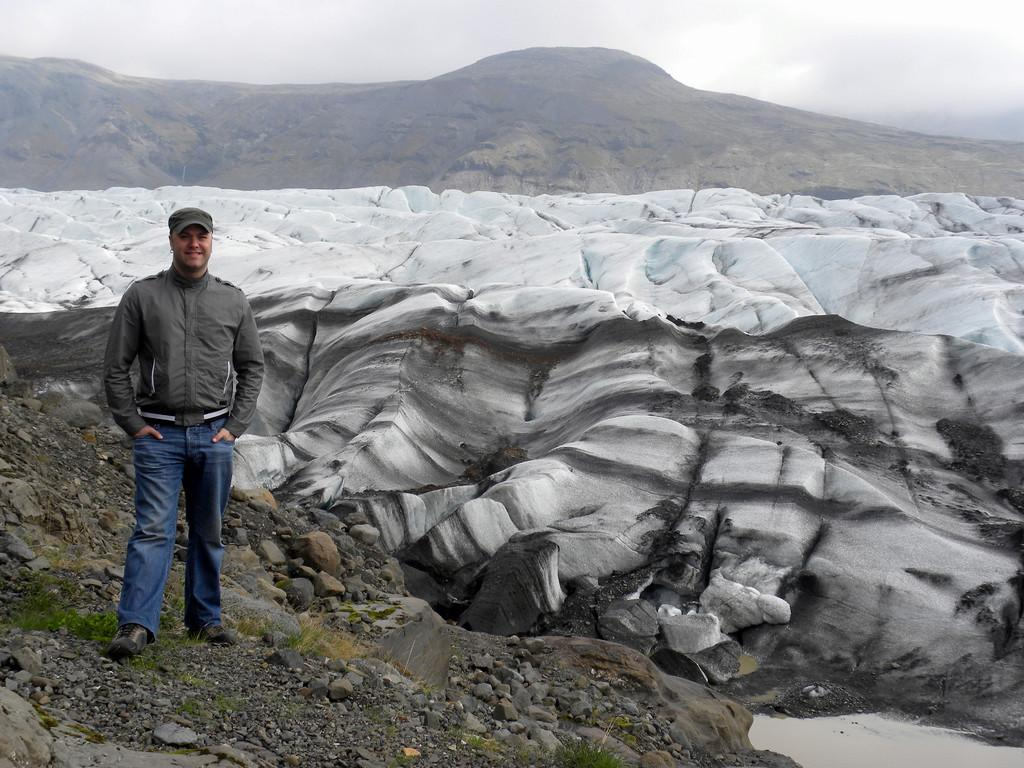What is the main subject of the image? There is a person standing in the image. What can be seen at the bottom of the image? There is water, stones, and grass at the bottom of the image. What is visible in the background of the image? There are mountains in the background of the image. What is visible at the top of the image? The sky is visible at the top of the image. Can you tell me how many aunts are swimming with the tiger in the image? There are no aunts or tigers present in the image. How does the person in the image blow bubbles underwater? There is no indication in the image that the person is blowing bubbles underwater. 